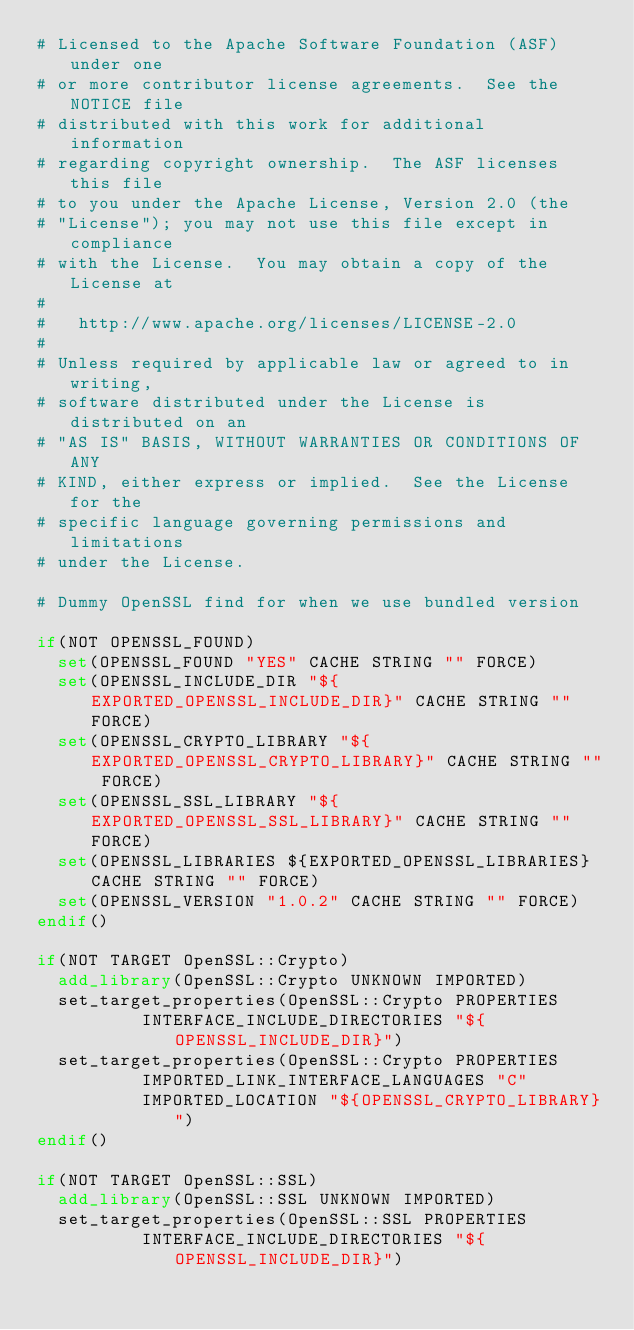<code> <loc_0><loc_0><loc_500><loc_500><_CMake_># Licensed to the Apache Software Foundation (ASF) under one
# or more contributor license agreements.  See the NOTICE file
# distributed with this work for additional information
# regarding copyright ownership.  The ASF licenses this file
# to you under the Apache License, Version 2.0 (the
# "License"); you may not use this file except in compliance
# with the License.  You may obtain a copy of the License at
# 
#   http://www.apache.org/licenses/LICENSE-2.0
# 
# Unless required by applicable law or agreed to in writing,
# software distributed under the License is distributed on an
# "AS IS" BASIS, WITHOUT WARRANTIES OR CONDITIONS OF ANY
# KIND, either express or implied.  See the License for the
# specific language governing permissions and limitations
# under the License.

# Dummy OpenSSL find for when we use bundled version

if(NOT OPENSSL_FOUND)
  set(OPENSSL_FOUND "YES" CACHE STRING "" FORCE)
  set(OPENSSL_INCLUDE_DIR "${EXPORTED_OPENSSL_INCLUDE_DIR}" CACHE STRING "" FORCE)
  set(OPENSSL_CRYPTO_LIBRARY "${EXPORTED_OPENSSL_CRYPTO_LIBRARY}" CACHE STRING "" FORCE)
  set(OPENSSL_SSL_LIBRARY "${EXPORTED_OPENSSL_SSL_LIBRARY}" CACHE STRING "" FORCE)
  set(OPENSSL_LIBRARIES ${EXPORTED_OPENSSL_LIBRARIES} CACHE STRING "" FORCE)
  set(OPENSSL_VERSION "1.0.2" CACHE STRING "" FORCE)
endif()

if(NOT TARGET OpenSSL::Crypto)
  add_library(OpenSSL::Crypto UNKNOWN IMPORTED)
  set_target_properties(OpenSSL::Crypto PROPERTIES
          INTERFACE_INCLUDE_DIRECTORIES "${OPENSSL_INCLUDE_DIR}")
  set_target_properties(OpenSSL::Crypto PROPERTIES
          IMPORTED_LINK_INTERFACE_LANGUAGES "C"
          IMPORTED_LOCATION "${OPENSSL_CRYPTO_LIBRARY}")
endif()

if(NOT TARGET OpenSSL::SSL)
  add_library(OpenSSL::SSL UNKNOWN IMPORTED)
  set_target_properties(OpenSSL::SSL PROPERTIES
          INTERFACE_INCLUDE_DIRECTORIES "${OPENSSL_INCLUDE_DIR}")</code> 